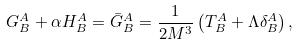Convert formula to latex. <formula><loc_0><loc_0><loc_500><loc_500>G _ { B } ^ { A } + \alpha H _ { B } ^ { A } = \bar { G } _ { B } ^ { A } = \frac { 1 } { 2 M ^ { 3 } } \left ( T _ { B } ^ { A } + \Lambda \delta _ { B } ^ { A } \right ) ,</formula> 